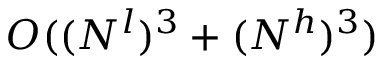Convert formula to latex. <formula><loc_0><loc_0><loc_500><loc_500>O ( ( N ^ { l } ) ^ { 3 } + ( N ^ { h } ) ^ { 3 } )</formula> 